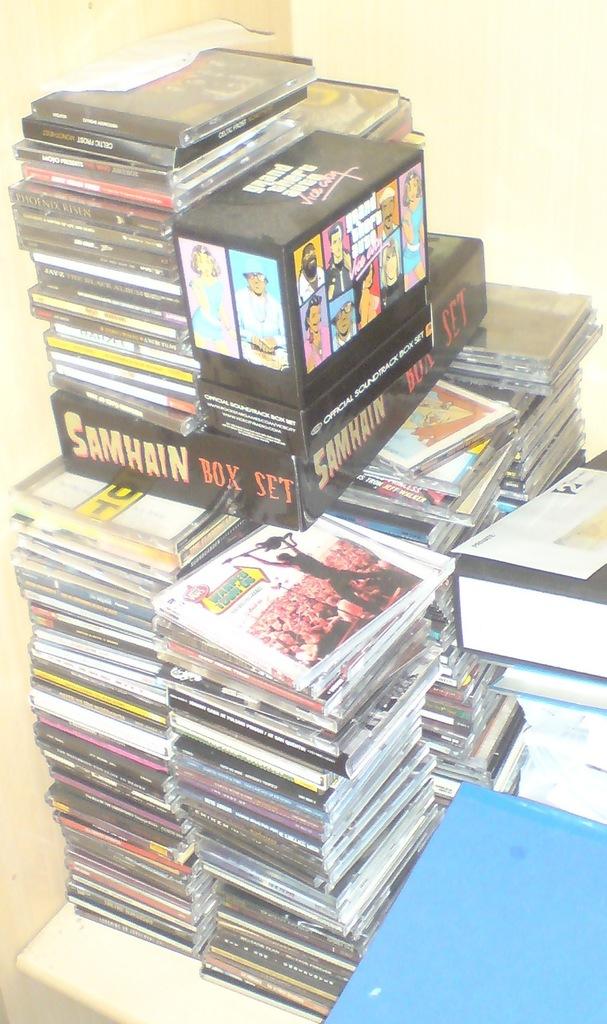What is the large box set of?
Give a very brief answer. Samhain. What video game is visible?
Offer a very short reply. Grand theft auto vice city. 